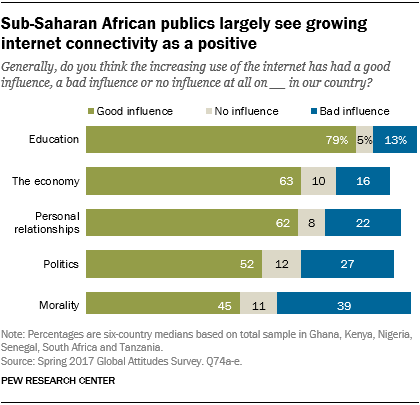List a handful of essential elements in this visual. To determine the ratio of the larger value to the smaller value, we took the medians of all the blue and green bars, and then divided the larger value by the smaller value, rounding the result to one decimal place. The final answer is approximately 2.8. The value of the green bar in the Morality category is 45. 